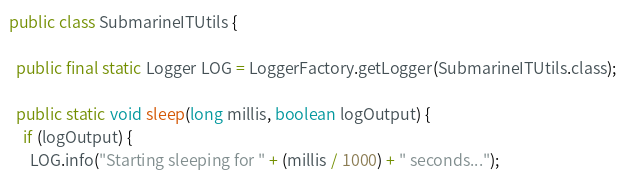Convert code to text. <code><loc_0><loc_0><loc_500><loc_500><_Java_>public class SubmarineITUtils {

  public final static Logger LOG = LoggerFactory.getLogger(SubmarineITUtils.class);

  public static void sleep(long millis, boolean logOutput) {
    if (logOutput) {
      LOG.info("Starting sleeping for " + (millis / 1000) + " seconds...");</code> 